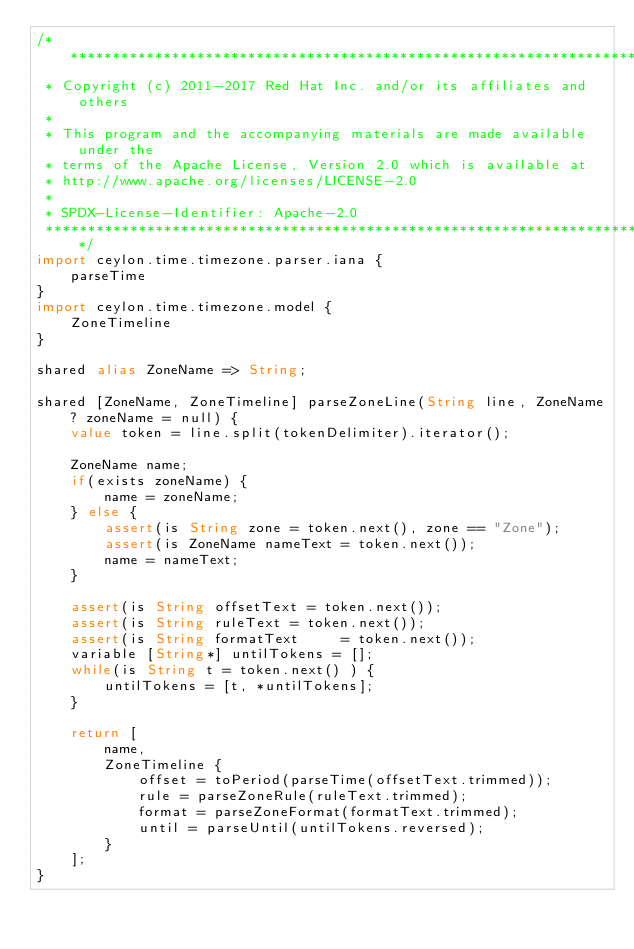<code> <loc_0><loc_0><loc_500><loc_500><_Ceylon_>/********************************************************************************
 * Copyright (c) 2011-2017 Red Hat Inc. and/or its affiliates and others
 *
 * This program and the accompanying materials are made available under the 
 * terms of the Apache License, Version 2.0 which is available at
 * http://www.apache.org/licenses/LICENSE-2.0
 *
 * SPDX-License-Identifier: Apache-2.0 
 ********************************************************************************/
import ceylon.time.timezone.parser.iana {
    parseTime
}
import ceylon.time.timezone.model {
    ZoneTimeline
}

shared alias ZoneName => String;

shared [ZoneName, ZoneTimeline] parseZoneLine(String line, ZoneName? zoneName = null) {
    value token = line.split(tokenDelimiter).iterator();
    
    ZoneName name;
    if(exists zoneName) {
        name = zoneName;
    } else {
        assert(is String zone = token.next(), zone == "Zone");
        assert(is ZoneName nameText = token.next());
        name = nameText;
    }
    
    assert(is String offsetText = token.next());
    assert(is String ruleText = token.next());
    assert(is String formatText     = token.next());
    variable [String*] untilTokens = [];
    while(is String t = token.next() ) {
        untilTokens = [t, *untilTokens];
    }
    
    return [
        name,
        ZoneTimeline {
            offset = toPeriod(parseTime(offsetText.trimmed));
            rule = parseZoneRule(ruleText.trimmed);
            format = parseZoneFormat(formatText.trimmed);
            until = parseUntil(untilTokens.reversed);
        }
    ];
}</code> 